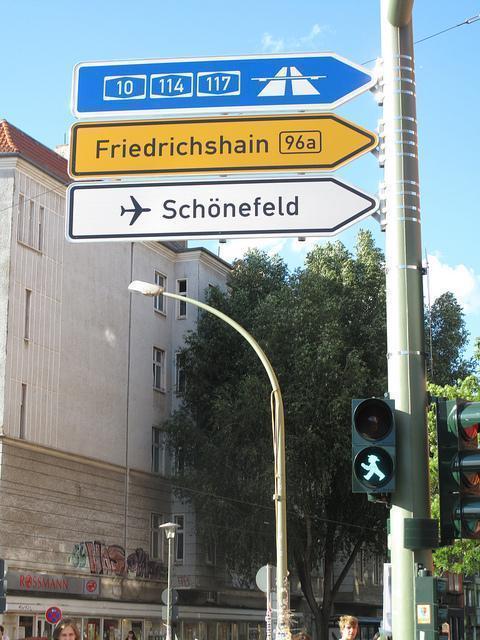This sign for the airport is most likely in which country?
Pick the right solution, then justify: 'Answer: answer
Rationale: rationale.'
Options: France, switzerland, germany, norway. Answer: germany.
Rationale: The schonefeld airport is located just outside of berlin. 